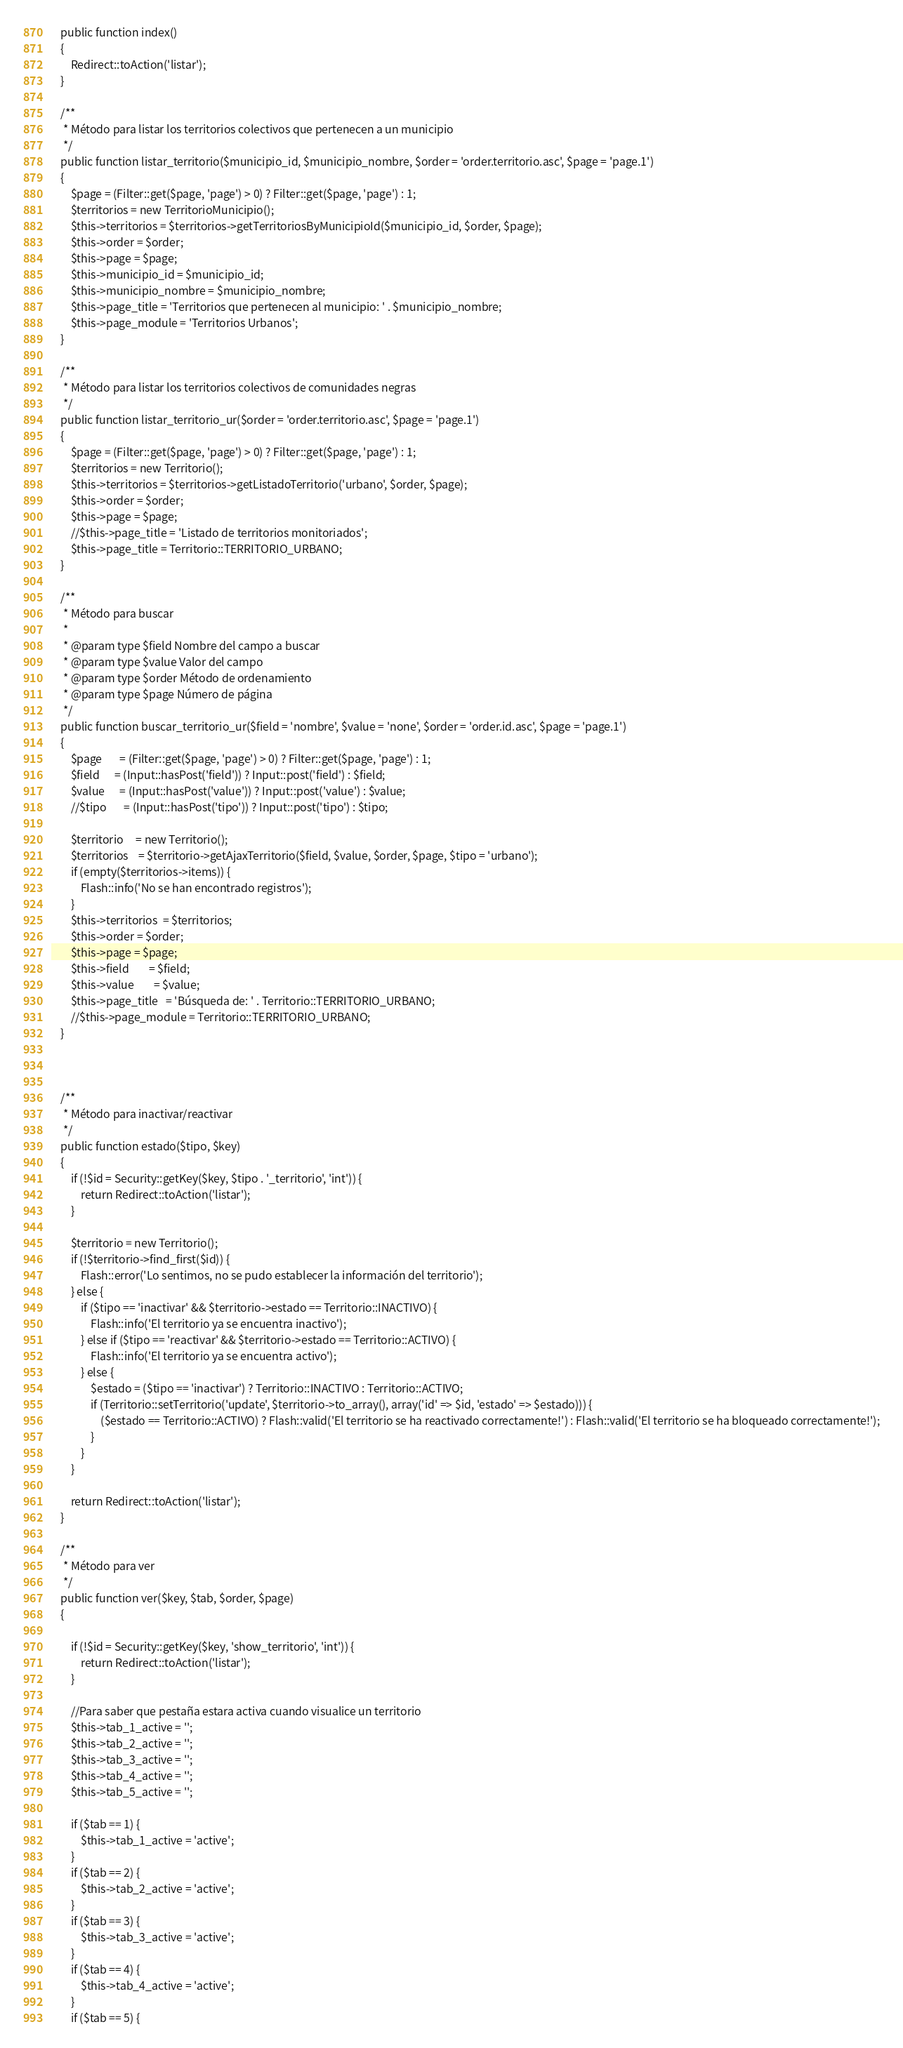<code> <loc_0><loc_0><loc_500><loc_500><_PHP_>    public function index()
    {
        Redirect::toAction('listar');
    }

    /**
     * Método para listar los territorios colectivos que pertenecen a un municipio
     */
    public function listar_territorio($municipio_id, $municipio_nombre, $order = 'order.territorio.asc', $page = 'page.1')
    {
        $page = (Filter::get($page, 'page') > 0) ? Filter::get($page, 'page') : 1;
        $territorios = new TerritorioMunicipio();
        $this->territorios = $territorios->getTerritoriosByMunicipioId($municipio_id, $order, $page);
        $this->order = $order;
        $this->page = $page;
        $this->municipio_id = $municipio_id;
        $this->municipio_nombre = $municipio_nombre;
        $this->page_title = 'Territorios que pertenecen al municipio: ' . $municipio_nombre;
        $this->page_module = 'Territorios Urbanos';
    }

    /**
     * Método para listar los territorios colectivos de comunidades negras
     */
    public function listar_territorio_ur($order = 'order.territorio.asc', $page = 'page.1')
    {
        $page = (Filter::get($page, 'page') > 0) ? Filter::get($page, 'page') : 1;
        $territorios = new Territorio();
        $this->territorios = $territorios->getListadoTerritorio('urbano', $order, $page);
        $this->order = $order;
        $this->page = $page;
        //$this->page_title = 'Listado de territorios monitoriados';
        $this->page_title = Territorio::TERRITORIO_URBANO;
    }

    /**
     * Método para buscar
     * 
     * @param type $field Nombre del campo a buscar
     * @param type $value Valor del campo
     * @param type $order Método de ordenamiento
     * @param type $page Número de página
     */
    public function buscar_territorio_ur($field = 'nombre', $value = 'none', $order = 'order.id.asc', $page = 'page.1')
    {
        $page       = (Filter::get($page, 'page') > 0) ? Filter::get($page, 'page') : 1;
        $field      = (Input::hasPost('field')) ? Input::post('field') : $field;
        $value      = (Input::hasPost('value')) ? Input::post('value') : $value;
        //$tipo       = (Input::hasPost('tipo')) ? Input::post('tipo') : $tipo;

        $territorio     = new Territorio();
        $territorios    = $territorio->getAjaxTerritorio($field, $value, $order, $page, $tipo = 'urbano');
        if (empty($territorios->items)) {
            Flash::info('No se han encontrado registros');
        }
        $this->territorios  = $territorios;
        $this->order = $order;
        $this->page = $page;
        $this->field        = $field;
        $this->value        = $value;
        $this->page_title   = 'Búsqueda de: ' . Territorio::TERRITORIO_URBANO;
        //$this->page_module = Territorio::TERRITORIO_URBANO;
    }



    /**
     * Método para inactivar/reactivar
     */
    public function estado($tipo, $key)
    {
        if (!$id = Security::getKey($key, $tipo . '_territorio', 'int')) {
            return Redirect::toAction('listar');
        }

        $territorio = new Territorio();
        if (!$territorio->find_first($id)) {
            Flash::error('Lo sentimos, no se pudo establecer la información del territorio');
        } else {
            if ($tipo == 'inactivar' && $territorio->estado == Territorio::INACTIVO) {
                Flash::info('El territorio ya se encuentra inactivo');
            } else if ($tipo == 'reactivar' && $territorio->estado == Territorio::ACTIVO) {
                Flash::info('El territorio ya se encuentra activo');
            } else {
                $estado = ($tipo == 'inactivar') ? Territorio::INACTIVO : Territorio::ACTIVO;
                if (Territorio::setTerritorio('update', $territorio->to_array(), array('id' => $id, 'estado' => $estado))) {
                    ($estado == Territorio::ACTIVO) ? Flash::valid('El territorio se ha reactivado correctamente!') : Flash::valid('El territorio se ha bloqueado correctamente!');
                }
            }
        }

        return Redirect::toAction('listar');
    }

    /**
     * Método para ver
     */
    public function ver($key, $tab, $order, $page)
    {

        if (!$id = Security::getKey($key, 'show_territorio', 'int')) {
            return Redirect::toAction('listar');
        }

        //Para saber que pestaña estara activa cuando visualice un territorio
        $this->tab_1_active = '';
        $this->tab_2_active = '';
        $this->tab_3_active = '';
        $this->tab_4_active = '';
        $this->tab_5_active = '';

        if ($tab == 1) {
            $this->tab_1_active = 'active';
        }
        if ($tab == 2) {
            $this->tab_2_active = 'active';
        }
        if ($tab == 3) {
            $this->tab_3_active = 'active';
        }
        if ($tab == 4) {
            $this->tab_4_active = 'active';
        }
        if ($tab == 5) {</code> 